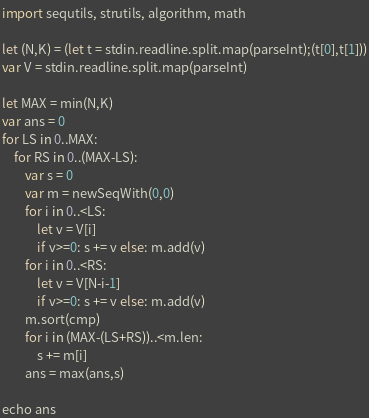<code> <loc_0><loc_0><loc_500><loc_500><_Nim_>import sequtils, strutils, algorithm, math

let (N,K) = (let t = stdin.readline.split.map(parseInt);(t[0],t[1]))
var V = stdin.readline.split.map(parseInt)

let MAX = min(N,K)
var ans = 0
for LS in 0..MAX:
    for RS in 0..(MAX-LS):
        var s = 0
        var m = newSeqWith(0,0)
        for i in 0..<LS:
            let v = V[i]
            if v>=0: s += v else: m.add(v)
        for i in 0..<RS:
            let v = V[N-i-1]
            if v>=0: s += v else: m.add(v)
        m.sort(cmp)
        for i in (MAX-(LS+RS))..<m.len:
            s += m[i]
        ans = max(ans,s)

echo ans</code> 